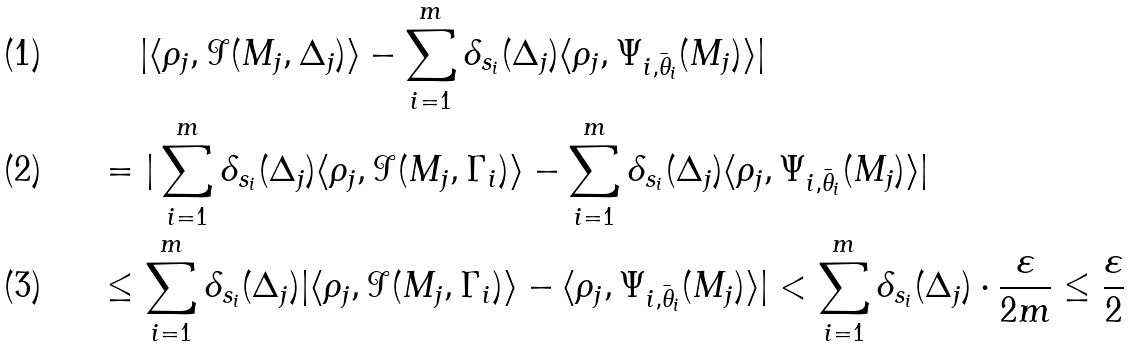Convert formula to latex. <formula><loc_0><loc_0><loc_500><loc_500>& \quad \, | \langle \rho _ { j } , \mathcal { I } ( M _ { j } , \Delta _ { j } ) \rangle - \sum _ { i = 1 } ^ { m } \delta _ { s _ { i } } ( \Delta _ { j } ) \langle \rho _ { j } , \Psi _ { i , \bar { \theta } _ { i } } ( M _ { j } ) \rangle | \\ & = | \sum _ { i = 1 } ^ { m } \delta _ { s _ { i } } ( \Delta _ { j } ) \langle \rho _ { j } , \mathcal { I } ( M _ { j } , \Gamma _ { i } ) \rangle - \sum _ { i = 1 } ^ { m } \delta _ { s _ { i } } ( \Delta _ { j } ) \langle \rho _ { j } , \Psi _ { i , \bar { \theta } _ { i } } ( M _ { j } ) \rangle | \\ & \leq \sum _ { i = 1 } ^ { m } \delta _ { s _ { i } } ( \Delta _ { j } ) | \langle \rho _ { j } , \mathcal { I } ( M _ { j } , \Gamma _ { i } ) \rangle - \langle \rho _ { j } , \Psi _ { i , \bar { \theta } _ { i } } ( M _ { j } ) \rangle | < \sum _ { i = 1 } ^ { m } \delta _ { s _ { i } } ( \Delta _ { j } ) \cdot \frac { \varepsilon } { 2 m } \leq \frac { \varepsilon } { 2 }</formula> 